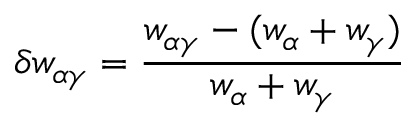Convert formula to latex. <formula><loc_0><loc_0><loc_500><loc_500>\delta w _ { \alpha \gamma } = \frac { w _ { \alpha \gamma } - ( w _ { \alpha } + w _ { \gamma } ) } { w _ { \alpha } + w _ { \gamma } }</formula> 